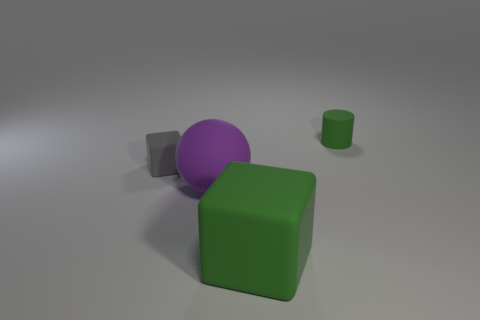How many things are purple spheres or small green objects on the right side of the gray block?
Provide a succinct answer. 2. How many large matte objects are left of the green object left of the small object behind the gray object?
Your response must be concise. 1. There is a big sphere that is the same material as the gray cube; what color is it?
Provide a succinct answer. Purple. Does the green object in front of the purple matte ball have the same size as the big purple thing?
Offer a very short reply. Yes. What number of things are either green rubber cylinders or blue metallic cubes?
Your response must be concise. 1. Are there any gray matte blocks of the same size as the rubber cylinder?
Your response must be concise. Yes. There is a block in front of the small gray rubber cube; does it have the same color as the small rubber cylinder?
Offer a terse response. Yes. How many purple objects are either big matte objects or large matte spheres?
Provide a short and direct response. 1. How many small matte cylinders are the same color as the small matte cube?
Provide a succinct answer. 0. Do the big green cube and the purple object have the same material?
Offer a very short reply. Yes. 